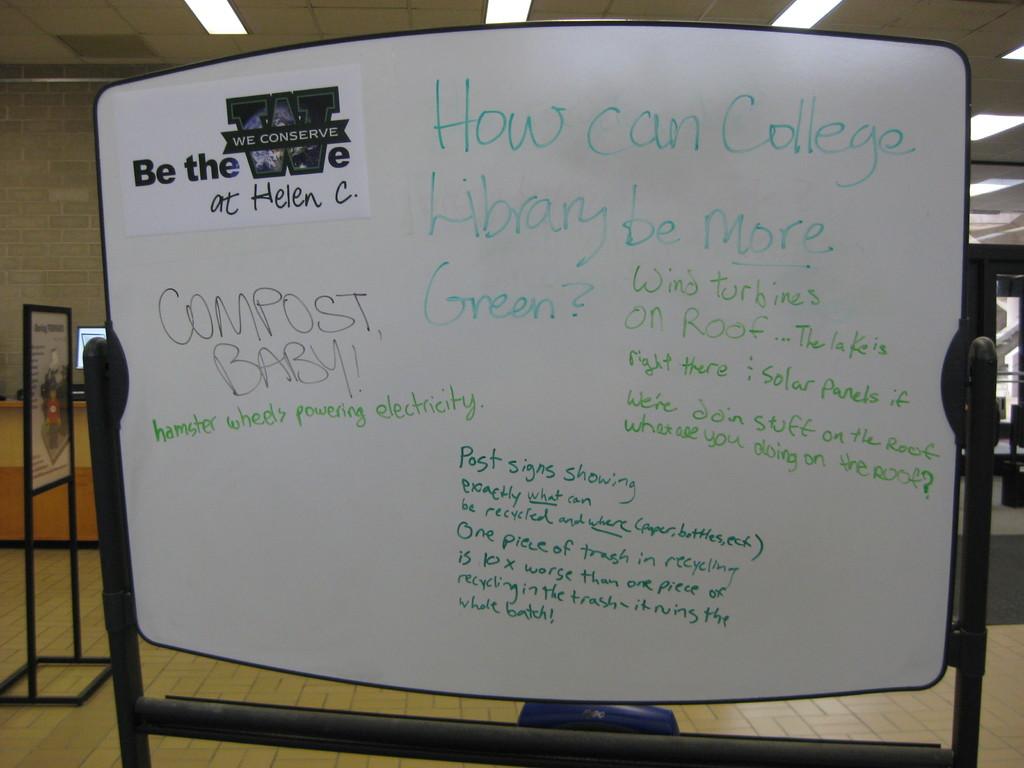What is the caption in the top left paper?
Ensure brevity in your answer.  Be the we. 